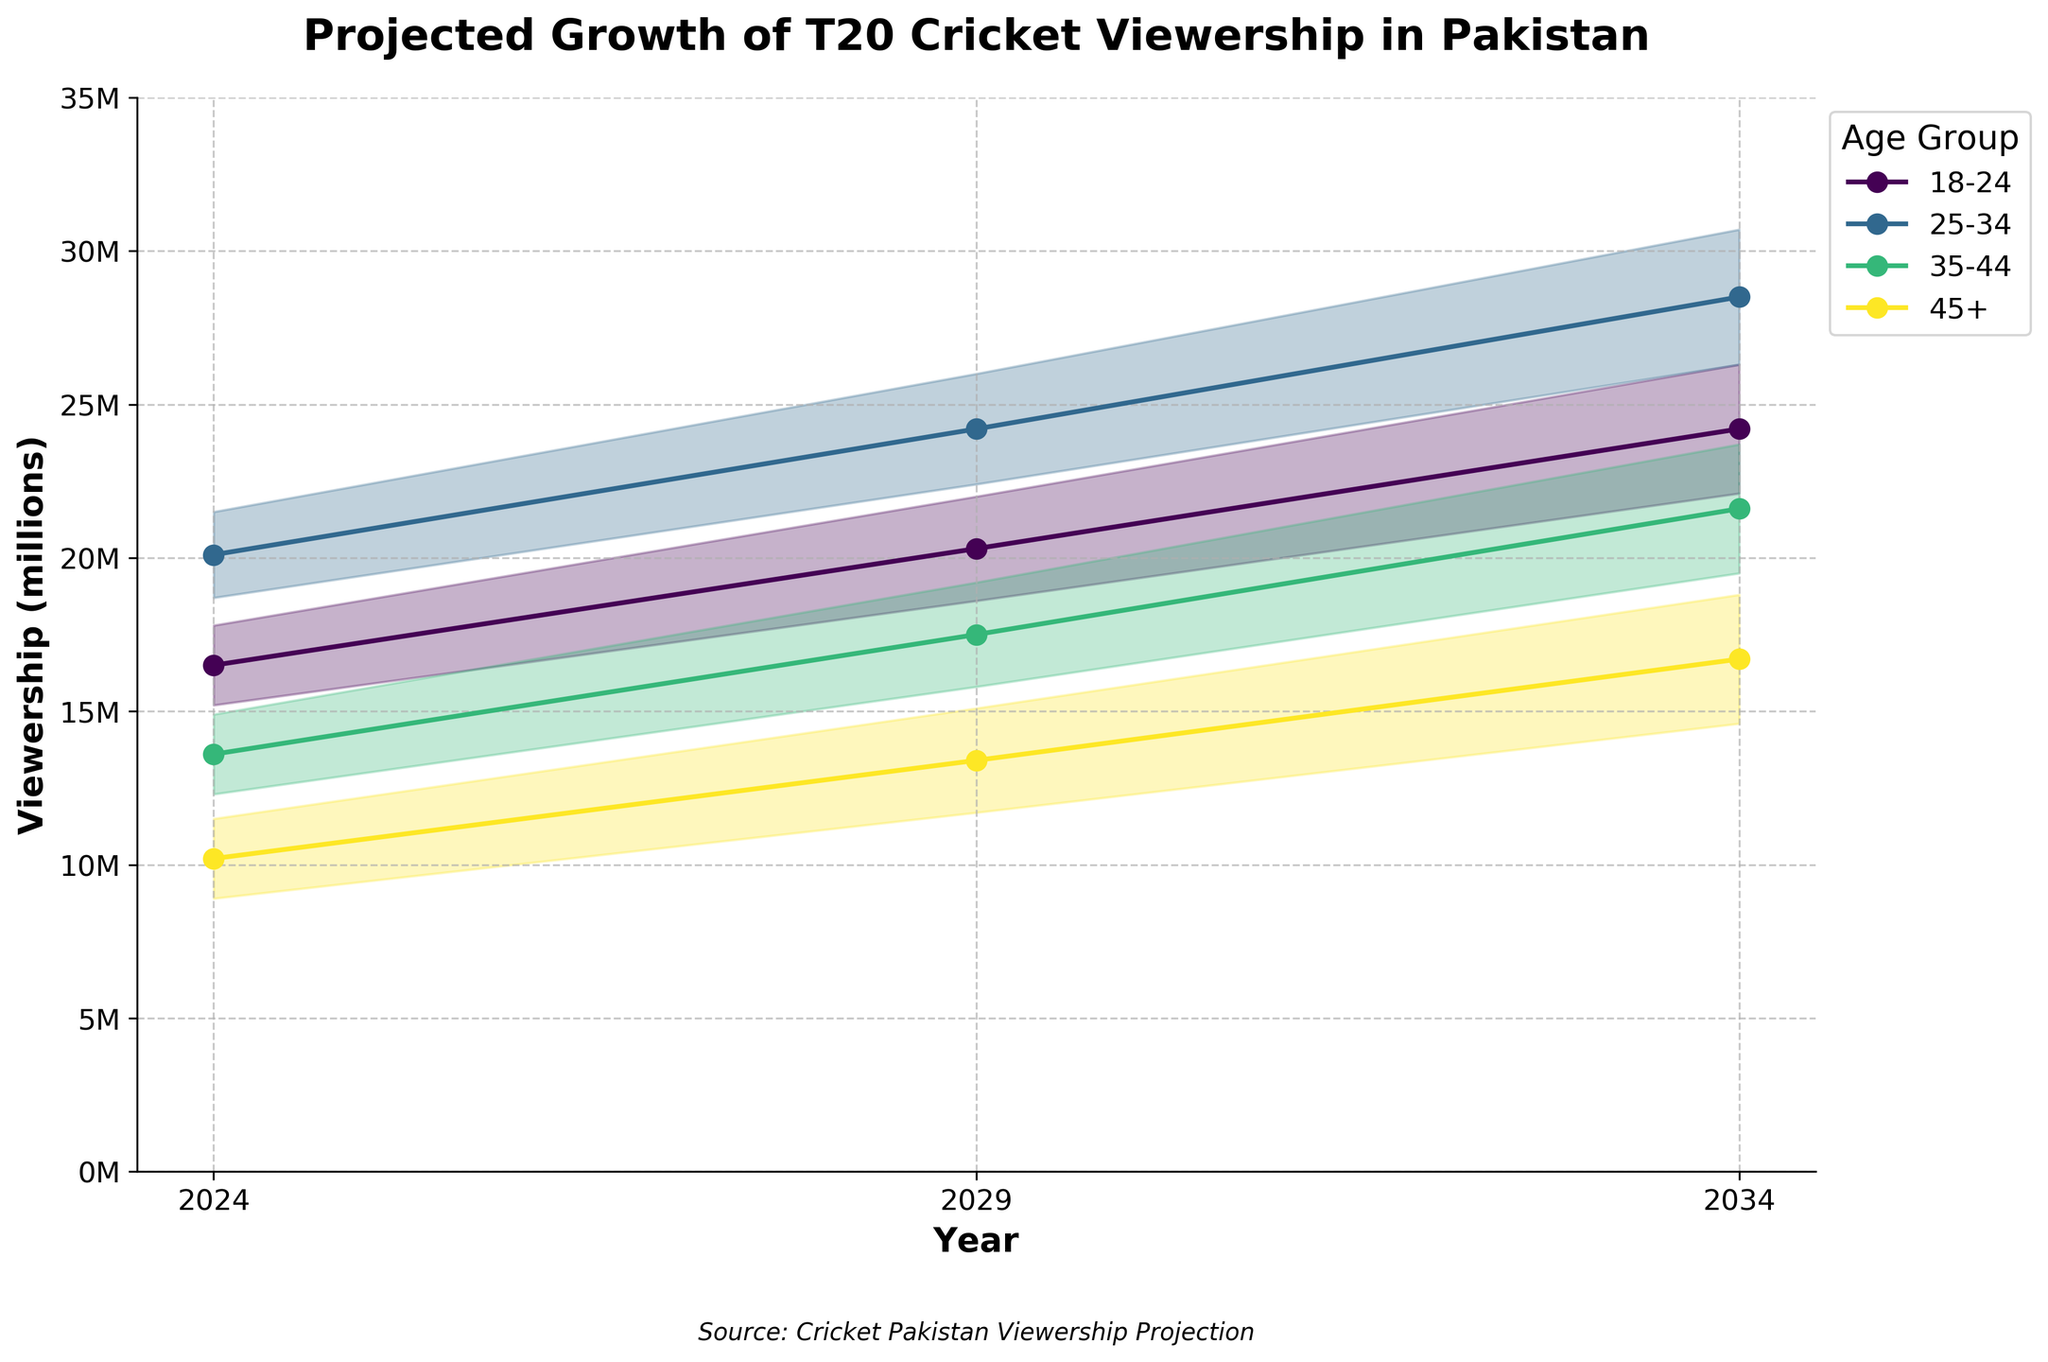How does the projected viewership for the age group 18-24 change from 2024 to 2034? Look at the Medium_Estimate line for the age group 18-24. In 2024, it starts at 16.5 million and increases to 24.2 million by 2034.
Answer: It increases from 16.5 million to 24.2 million Which age group is projected to have the highest viewership in 2034? Compare the Medium_Estimate values for all age groups in 2034. The highest value is for the 25-34 age group at 28.5 million.
Answer: The 25-34 age group What is the projected range of viewership for the age group 45+ in 2029? Find the Low_Estimate and High_Estimate for the 45+ age group in 2029, which are 11.7 million and 15.1 million, respectively.
Answer: 11.7 million to 15.1 million Which age group has the smallest projected growth in viewership from 2024 to 2034? Calculate the growth (difference between 2034 and 2024 Medium_Estimate) for each age group. The smallest growth is in the 45+ age group, increasing from 10.2 million to 16.7 million.
Answer: The 45+ age group What is the difference in projected viewership between the age groups 25-34 and 35-44 in 2029? Subtract the Medium_Estimate of 35-44 (17.5 million) from 25-34 (24.2 million) for 2029. The difference is 6.7 million.
Answer: 6.7 million Which age group shows the largest increase in the upper bound projection from 2024 to 2034? Calculate the increase for High_Estimate for each age group between 2024 and 2034. The 18-24 age group shows the largest increase from 17.8 million to 26.3 million, which is an increase of 8.5 million.
Answer: 18-24 age group How does the medium projection for the age group 35-44 in 2024 compare with the medium projection for the age group 18-24 in 2034? The Medium_Estimate for the 35-44 age group in 2024 is 13.6 million, while for the 18-24 age group in 2034, it is 24.2 million.
Answer: 13.6 million vs 24.2 million 